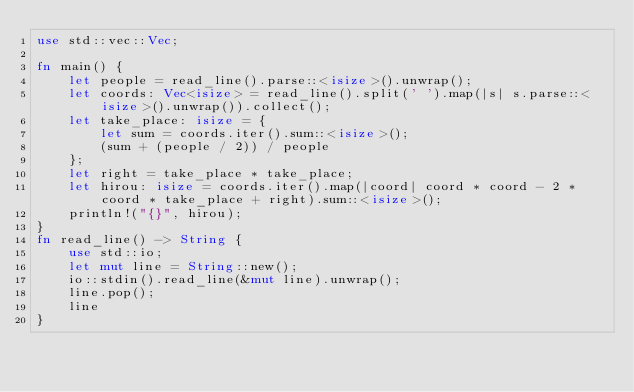Convert code to text. <code><loc_0><loc_0><loc_500><loc_500><_Rust_>use std::vec::Vec;

fn main() {
    let people = read_line().parse::<isize>().unwrap();
    let coords: Vec<isize> = read_line().split(' ').map(|s| s.parse::<isize>().unwrap()).collect();
    let take_place: isize = {
        let sum = coords.iter().sum::<isize>();
        (sum + (people / 2)) / people
    };
    let right = take_place * take_place;
    let hirou: isize = coords.iter().map(|coord| coord * coord - 2 * coord * take_place + right).sum::<isize>();
    println!("{}", hirou);
}
fn read_line() -> String {
    use std::io;
    let mut line = String::new();
    io::stdin().read_line(&mut line).unwrap();
    line.pop();
    line
}</code> 